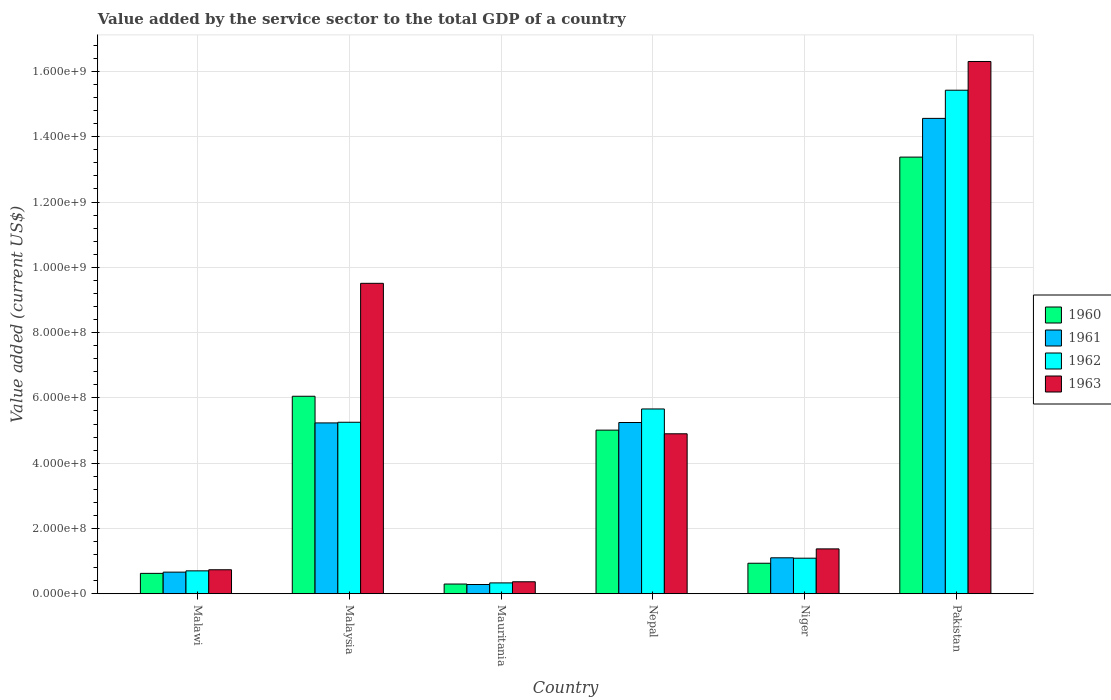How many different coloured bars are there?
Ensure brevity in your answer.  4. How many groups of bars are there?
Provide a succinct answer. 6. Are the number of bars per tick equal to the number of legend labels?
Provide a succinct answer. Yes. Are the number of bars on each tick of the X-axis equal?
Provide a short and direct response. Yes. How many bars are there on the 1st tick from the left?
Offer a very short reply. 4. How many bars are there on the 3rd tick from the right?
Provide a short and direct response. 4. What is the label of the 2nd group of bars from the left?
Provide a short and direct response. Malaysia. What is the value added by the service sector to the total GDP in 1960 in Malaysia?
Offer a terse response. 6.05e+08. Across all countries, what is the maximum value added by the service sector to the total GDP in 1962?
Give a very brief answer. 1.54e+09. Across all countries, what is the minimum value added by the service sector to the total GDP in 1960?
Provide a succinct answer. 2.97e+07. In which country was the value added by the service sector to the total GDP in 1962 minimum?
Ensure brevity in your answer.  Mauritania. What is the total value added by the service sector to the total GDP in 1962 in the graph?
Your answer should be compact. 2.85e+09. What is the difference between the value added by the service sector to the total GDP in 1961 in Malawi and that in Mauritania?
Your answer should be very brief. 3.79e+07. What is the difference between the value added by the service sector to the total GDP in 1962 in Nepal and the value added by the service sector to the total GDP in 1963 in Niger?
Offer a terse response. 4.29e+08. What is the average value added by the service sector to the total GDP in 1962 per country?
Make the answer very short. 4.74e+08. What is the difference between the value added by the service sector to the total GDP of/in 1961 and value added by the service sector to the total GDP of/in 1963 in Niger?
Keep it short and to the point. -2.73e+07. What is the ratio of the value added by the service sector to the total GDP in 1960 in Niger to that in Pakistan?
Keep it short and to the point. 0.07. Is the value added by the service sector to the total GDP in 1961 in Malaysia less than that in Niger?
Offer a very short reply. No. Is the difference between the value added by the service sector to the total GDP in 1961 in Nepal and Niger greater than the difference between the value added by the service sector to the total GDP in 1963 in Nepal and Niger?
Provide a succinct answer. Yes. What is the difference between the highest and the second highest value added by the service sector to the total GDP in 1961?
Your answer should be compact. 9.33e+08. What is the difference between the highest and the lowest value added by the service sector to the total GDP in 1960?
Your answer should be compact. 1.31e+09. Is it the case that in every country, the sum of the value added by the service sector to the total GDP in 1961 and value added by the service sector to the total GDP in 1962 is greater than the sum of value added by the service sector to the total GDP in 1963 and value added by the service sector to the total GDP in 1960?
Keep it short and to the point. No. Is it the case that in every country, the sum of the value added by the service sector to the total GDP in 1962 and value added by the service sector to the total GDP in 1960 is greater than the value added by the service sector to the total GDP in 1963?
Make the answer very short. Yes. How many bars are there?
Give a very brief answer. 24. Are all the bars in the graph horizontal?
Offer a terse response. No. Are the values on the major ticks of Y-axis written in scientific E-notation?
Give a very brief answer. Yes. What is the title of the graph?
Your response must be concise. Value added by the service sector to the total GDP of a country. What is the label or title of the Y-axis?
Give a very brief answer. Value added (current US$). What is the Value added (current US$) of 1960 in Malawi?
Offer a very short reply. 6.24e+07. What is the Value added (current US$) in 1961 in Malawi?
Offer a very short reply. 6.62e+07. What is the Value added (current US$) in 1962 in Malawi?
Provide a succinct answer. 7.01e+07. What is the Value added (current US$) of 1963 in Malawi?
Give a very brief answer. 7.35e+07. What is the Value added (current US$) of 1960 in Malaysia?
Offer a terse response. 6.05e+08. What is the Value added (current US$) in 1961 in Malaysia?
Your answer should be very brief. 5.23e+08. What is the Value added (current US$) in 1962 in Malaysia?
Your answer should be compact. 5.25e+08. What is the Value added (current US$) in 1963 in Malaysia?
Ensure brevity in your answer.  9.51e+08. What is the Value added (current US$) in 1960 in Mauritania?
Give a very brief answer. 2.97e+07. What is the Value added (current US$) of 1961 in Mauritania?
Provide a succinct answer. 2.83e+07. What is the Value added (current US$) in 1962 in Mauritania?
Give a very brief answer. 3.32e+07. What is the Value added (current US$) in 1963 in Mauritania?
Offer a very short reply. 3.67e+07. What is the Value added (current US$) in 1960 in Nepal?
Make the answer very short. 5.01e+08. What is the Value added (current US$) of 1961 in Nepal?
Your answer should be compact. 5.25e+08. What is the Value added (current US$) in 1962 in Nepal?
Offer a very short reply. 5.66e+08. What is the Value added (current US$) in 1963 in Nepal?
Keep it short and to the point. 4.90e+08. What is the Value added (current US$) of 1960 in Niger?
Offer a very short reply. 9.35e+07. What is the Value added (current US$) of 1961 in Niger?
Your answer should be compact. 1.10e+08. What is the Value added (current US$) in 1962 in Niger?
Give a very brief answer. 1.09e+08. What is the Value added (current US$) in 1963 in Niger?
Keep it short and to the point. 1.37e+08. What is the Value added (current US$) in 1960 in Pakistan?
Provide a succinct answer. 1.34e+09. What is the Value added (current US$) of 1961 in Pakistan?
Ensure brevity in your answer.  1.46e+09. What is the Value added (current US$) of 1962 in Pakistan?
Provide a short and direct response. 1.54e+09. What is the Value added (current US$) in 1963 in Pakistan?
Provide a short and direct response. 1.63e+09. Across all countries, what is the maximum Value added (current US$) in 1960?
Offer a very short reply. 1.34e+09. Across all countries, what is the maximum Value added (current US$) of 1961?
Your answer should be compact. 1.46e+09. Across all countries, what is the maximum Value added (current US$) of 1962?
Your answer should be very brief. 1.54e+09. Across all countries, what is the maximum Value added (current US$) of 1963?
Ensure brevity in your answer.  1.63e+09. Across all countries, what is the minimum Value added (current US$) of 1960?
Provide a short and direct response. 2.97e+07. Across all countries, what is the minimum Value added (current US$) of 1961?
Offer a terse response. 2.83e+07. Across all countries, what is the minimum Value added (current US$) of 1962?
Keep it short and to the point. 3.32e+07. Across all countries, what is the minimum Value added (current US$) in 1963?
Make the answer very short. 3.67e+07. What is the total Value added (current US$) in 1960 in the graph?
Your response must be concise. 2.63e+09. What is the total Value added (current US$) of 1961 in the graph?
Make the answer very short. 2.71e+09. What is the total Value added (current US$) of 1962 in the graph?
Offer a very short reply. 2.85e+09. What is the total Value added (current US$) of 1963 in the graph?
Offer a very short reply. 3.32e+09. What is the difference between the Value added (current US$) of 1960 in Malawi and that in Malaysia?
Keep it short and to the point. -5.43e+08. What is the difference between the Value added (current US$) of 1961 in Malawi and that in Malaysia?
Make the answer very short. -4.57e+08. What is the difference between the Value added (current US$) of 1962 in Malawi and that in Malaysia?
Offer a very short reply. -4.55e+08. What is the difference between the Value added (current US$) of 1963 in Malawi and that in Malaysia?
Make the answer very short. -8.78e+08. What is the difference between the Value added (current US$) of 1960 in Malawi and that in Mauritania?
Provide a short and direct response. 3.27e+07. What is the difference between the Value added (current US$) in 1961 in Malawi and that in Mauritania?
Offer a terse response. 3.79e+07. What is the difference between the Value added (current US$) in 1962 in Malawi and that in Mauritania?
Your answer should be compact. 3.69e+07. What is the difference between the Value added (current US$) in 1963 in Malawi and that in Mauritania?
Provide a short and direct response. 3.68e+07. What is the difference between the Value added (current US$) in 1960 in Malawi and that in Nepal?
Ensure brevity in your answer.  -4.39e+08. What is the difference between the Value added (current US$) in 1961 in Malawi and that in Nepal?
Your answer should be compact. -4.58e+08. What is the difference between the Value added (current US$) in 1962 in Malawi and that in Nepal?
Ensure brevity in your answer.  -4.96e+08. What is the difference between the Value added (current US$) of 1963 in Malawi and that in Nepal?
Offer a terse response. -4.17e+08. What is the difference between the Value added (current US$) in 1960 in Malawi and that in Niger?
Your response must be concise. -3.10e+07. What is the difference between the Value added (current US$) of 1961 in Malawi and that in Niger?
Make the answer very short. -4.39e+07. What is the difference between the Value added (current US$) of 1962 in Malawi and that in Niger?
Your answer should be very brief. -3.88e+07. What is the difference between the Value added (current US$) of 1963 in Malawi and that in Niger?
Your answer should be compact. -6.39e+07. What is the difference between the Value added (current US$) in 1960 in Malawi and that in Pakistan?
Provide a short and direct response. -1.28e+09. What is the difference between the Value added (current US$) in 1961 in Malawi and that in Pakistan?
Give a very brief answer. -1.39e+09. What is the difference between the Value added (current US$) in 1962 in Malawi and that in Pakistan?
Your response must be concise. -1.47e+09. What is the difference between the Value added (current US$) of 1963 in Malawi and that in Pakistan?
Your answer should be compact. -1.56e+09. What is the difference between the Value added (current US$) in 1960 in Malaysia and that in Mauritania?
Your answer should be very brief. 5.75e+08. What is the difference between the Value added (current US$) in 1961 in Malaysia and that in Mauritania?
Offer a very short reply. 4.95e+08. What is the difference between the Value added (current US$) in 1962 in Malaysia and that in Mauritania?
Your response must be concise. 4.92e+08. What is the difference between the Value added (current US$) in 1963 in Malaysia and that in Mauritania?
Make the answer very short. 9.14e+08. What is the difference between the Value added (current US$) of 1960 in Malaysia and that in Nepal?
Give a very brief answer. 1.04e+08. What is the difference between the Value added (current US$) of 1961 in Malaysia and that in Nepal?
Give a very brief answer. -1.26e+06. What is the difference between the Value added (current US$) of 1962 in Malaysia and that in Nepal?
Your answer should be compact. -4.07e+07. What is the difference between the Value added (current US$) of 1963 in Malaysia and that in Nepal?
Make the answer very short. 4.61e+08. What is the difference between the Value added (current US$) in 1960 in Malaysia and that in Niger?
Offer a terse response. 5.12e+08. What is the difference between the Value added (current US$) in 1961 in Malaysia and that in Niger?
Offer a very short reply. 4.13e+08. What is the difference between the Value added (current US$) in 1962 in Malaysia and that in Niger?
Your answer should be compact. 4.16e+08. What is the difference between the Value added (current US$) of 1963 in Malaysia and that in Niger?
Ensure brevity in your answer.  8.14e+08. What is the difference between the Value added (current US$) of 1960 in Malaysia and that in Pakistan?
Provide a short and direct response. -7.33e+08. What is the difference between the Value added (current US$) in 1961 in Malaysia and that in Pakistan?
Your answer should be compact. -9.33e+08. What is the difference between the Value added (current US$) in 1962 in Malaysia and that in Pakistan?
Your answer should be compact. -1.02e+09. What is the difference between the Value added (current US$) of 1963 in Malaysia and that in Pakistan?
Offer a very short reply. -6.80e+08. What is the difference between the Value added (current US$) of 1960 in Mauritania and that in Nepal?
Your response must be concise. -4.72e+08. What is the difference between the Value added (current US$) in 1961 in Mauritania and that in Nepal?
Your response must be concise. -4.96e+08. What is the difference between the Value added (current US$) in 1962 in Mauritania and that in Nepal?
Provide a short and direct response. -5.33e+08. What is the difference between the Value added (current US$) of 1963 in Mauritania and that in Nepal?
Your answer should be very brief. -4.53e+08. What is the difference between the Value added (current US$) in 1960 in Mauritania and that in Niger?
Offer a terse response. -6.37e+07. What is the difference between the Value added (current US$) of 1961 in Mauritania and that in Niger?
Make the answer very short. -8.18e+07. What is the difference between the Value added (current US$) of 1962 in Mauritania and that in Niger?
Give a very brief answer. -7.57e+07. What is the difference between the Value added (current US$) of 1963 in Mauritania and that in Niger?
Ensure brevity in your answer.  -1.01e+08. What is the difference between the Value added (current US$) of 1960 in Mauritania and that in Pakistan?
Provide a short and direct response. -1.31e+09. What is the difference between the Value added (current US$) in 1961 in Mauritania and that in Pakistan?
Keep it short and to the point. -1.43e+09. What is the difference between the Value added (current US$) in 1962 in Mauritania and that in Pakistan?
Give a very brief answer. -1.51e+09. What is the difference between the Value added (current US$) in 1963 in Mauritania and that in Pakistan?
Your answer should be very brief. -1.59e+09. What is the difference between the Value added (current US$) of 1960 in Nepal and that in Niger?
Provide a short and direct response. 4.08e+08. What is the difference between the Value added (current US$) of 1961 in Nepal and that in Niger?
Provide a succinct answer. 4.14e+08. What is the difference between the Value added (current US$) in 1962 in Nepal and that in Niger?
Make the answer very short. 4.57e+08. What is the difference between the Value added (current US$) in 1963 in Nepal and that in Niger?
Offer a very short reply. 3.53e+08. What is the difference between the Value added (current US$) of 1960 in Nepal and that in Pakistan?
Provide a short and direct response. -8.36e+08. What is the difference between the Value added (current US$) in 1961 in Nepal and that in Pakistan?
Give a very brief answer. -9.32e+08. What is the difference between the Value added (current US$) in 1962 in Nepal and that in Pakistan?
Give a very brief answer. -9.77e+08. What is the difference between the Value added (current US$) in 1963 in Nepal and that in Pakistan?
Keep it short and to the point. -1.14e+09. What is the difference between the Value added (current US$) in 1960 in Niger and that in Pakistan?
Your answer should be compact. -1.24e+09. What is the difference between the Value added (current US$) of 1961 in Niger and that in Pakistan?
Ensure brevity in your answer.  -1.35e+09. What is the difference between the Value added (current US$) in 1962 in Niger and that in Pakistan?
Your answer should be compact. -1.43e+09. What is the difference between the Value added (current US$) in 1963 in Niger and that in Pakistan?
Ensure brevity in your answer.  -1.49e+09. What is the difference between the Value added (current US$) of 1960 in Malawi and the Value added (current US$) of 1961 in Malaysia?
Provide a succinct answer. -4.61e+08. What is the difference between the Value added (current US$) of 1960 in Malawi and the Value added (current US$) of 1962 in Malaysia?
Ensure brevity in your answer.  -4.63e+08. What is the difference between the Value added (current US$) in 1960 in Malawi and the Value added (current US$) in 1963 in Malaysia?
Make the answer very short. -8.89e+08. What is the difference between the Value added (current US$) of 1961 in Malawi and the Value added (current US$) of 1962 in Malaysia?
Keep it short and to the point. -4.59e+08. What is the difference between the Value added (current US$) of 1961 in Malawi and the Value added (current US$) of 1963 in Malaysia?
Provide a succinct answer. -8.85e+08. What is the difference between the Value added (current US$) in 1962 in Malawi and the Value added (current US$) in 1963 in Malaysia?
Your response must be concise. -8.81e+08. What is the difference between the Value added (current US$) of 1960 in Malawi and the Value added (current US$) of 1961 in Mauritania?
Your response must be concise. 3.41e+07. What is the difference between the Value added (current US$) in 1960 in Malawi and the Value added (current US$) in 1962 in Mauritania?
Give a very brief answer. 2.92e+07. What is the difference between the Value added (current US$) of 1960 in Malawi and the Value added (current US$) of 1963 in Mauritania?
Offer a terse response. 2.58e+07. What is the difference between the Value added (current US$) of 1961 in Malawi and the Value added (current US$) of 1962 in Mauritania?
Your response must be concise. 3.30e+07. What is the difference between the Value added (current US$) of 1961 in Malawi and the Value added (current US$) of 1963 in Mauritania?
Your answer should be very brief. 2.96e+07. What is the difference between the Value added (current US$) in 1962 in Malawi and the Value added (current US$) in 1963 in Mauritania?
Your response must be concise. 3.35e+07. What is the difference between the Value added (current US$) of 1960 in Malawi and the Value added (current US$) of 1961 in Nepal?
Your answer should be compact. -4.62e+08. What is the difference between the Value added (current US$) in 1960 in Malawi and the Value added (current US$) in 1962 in Nepal?
Provide a succinct answer. -5.04e+08. What is the difference between the Value added (current US$) of 1960 in Malawi and the Value added (current US$) of 1963 in Nepal?
Keep it short and to the point. -4.28e+08. What is the difference between the Value added (current US$) of 1961 in Malawi and the Value added (current US$) of 1962 in Nepal?
Ensure brevity in your answer.  -5.00e+08. What is the difference between the Value added (current US$) in 1961 in Malawi and the Value added (current US$) in 1963 in Nepal?
Provide a succinct answer. -4.24e+08. What is the difference between the Value added (current US$) in 1962 in Malawi and the Value added (current US$) in 1963 in Nepal?
Make the answer very short. -4.20e+08. What is the difference between the Value added (current US$) of 1960 in Malawi and the Value added (current US$) of 1961 in Niger?
Your answer should be very brief. -4.77e+07. What is the difference between the Value added (current US$) of 1960 in Malawi and the Value added (current US$) of 1962 in Niger?
Offer a very short reply. -4.65e+07. What is the difference between the Value added (current US$) of 1960 in Malawi and the Value added (current US$) of 1963 in Niger?
Give a very brief answer. -7.50e+07. What is the difference between the Value added (current US$) of 1961 in Malawi and the Value added (current US$) of 1962 in Niger?
Your answer should be very brief. -4.27e+07. What is the difference between the Value added (current US$) in 1961 in Malawi and the Value added (current US$) in 1963 in Niger?
Your response must be concise. -7.12e+07. What is the difference between the Value added (current US$) of 1962 in Malawi and the Value added (current US$) of 1963 in Niger?
Keep it short and to the point. -6.73e+07. What is the difference between the Value added (current US$) of 1960 in Malawi and the Value added (current US$) of 1961 in Pakistan?
Your answer should be very brief. -1.39e+09. What is the difference between the Value added (current US$) in 1960 in Malawi and the Value added (current US$) in 1962 in Pakistan?
Your response must be concise. -1.48e+09. What is the difference between the Value added (current US$) of 1960 in Malawi and the Value added (current US$) of 1963 in Pakistan?
Keep it short and to the point. -1.57e+09. What is the difference between the Value added (current US$) of 1961 in Malawi and the Value added (current US$) of 1962 in Pakistan?
Ensure brevity in your answer.  -1.48e+09. What is the difference between the Value added (current US$) in 1961 in Malawi and the Value added (current US$) in 1963 in Pakistan?
Keep it short and to the point. -1.56e+09. What is the difference between the Value added (current US$) of 1962 in Malawi and the Value added (current US$) of 1963 in Pakistan?
Your answer should be compact. -1.56e+09. What is the difference between the Value added (current US$) of 1960 in Malaysia and the Value added (current US$) of 1961 in Mauritania?
Keep it short and to the point. 5.77e+08. What is the difference between the Value added (current US$) in 1960 in Malaysia and the Value added (current US$) in 1962 in Mauritania?
Your answer should be compact. 5.72e+08. What is the difference between the Value added (current US$) in 1960 in Malaysia and the Value added (current US$) in 1963 in Mauritania?
Provide a succinct answer. 5.68e+08. What is the difference between the Value added (current US$) of 1961 in Malaysia and the Value added (current US$) of 1962 in Mauritania?
Make the answer very short. 4.90e+08. What is the difference between the Value added (current US$) of 1961 in Malaysia and the Value added (current US$) of 1963 in Mauritania?
Your response must be concise. 4.87e+08. What is the difference between the Value added (current US$) in 1962 in Malaysia and the Value added (current US$) in 1963 in Mauritania?
Your response must be concise. 4.89e+08. What is the difference between the Value added (current US$) in 1960 in Malaysia and the Value added (current US$) in 1961 in Nepal?
Provide a short and direct response. 8.04e+07. What is the difference between the Value added (current US$) of 1960 in Malaysia and the Value added (current US$) of 1962 in Nepal?
Provide a short and direct response. 3.89e+07. What is the difference between the Value added (current US$) of 1960 in Malaysia and the Value added (current US$) of 1963 in Nepal?
Keep it short and to the point. 1.15e+08. What is the difference between the Value added (current US$) of 1961 in Malaysia and the Value added (current US$) of 1962 in Nepal?
Offer a very short reply. -4.27e+07. What is the difference between the Value added (current US$) in 1961 in Malaysia and the Value added (current US$) in 1963 in Nepal?
Offer a very short reply. 3.33e+07. What is the difference between the Value added (current US$) in 1962 in Malaysia and the Value added (current US$) in 1963 in Nepal?
Offer a very short reply. 3.53e+07. What is the difference between the Value added (current US$) in 1960 in Malaysia and the Value added (current US$) in 1961 in Niger?
Provide a succinct answer. 4.95e+08. What is the difference between the Value added (current US$) in 1960 in Malaysia and the Value added (current US$) in 1962 in Niger?
Provide a short and direct response. 4.96e+08. What is the difference between the Value added (current US$) of 1960 in Malaysia and the Value added (current US$) of 1963 in Niger?
Provide a succinct answer. 4.68e+08. What is the difference between the Value added (current US$) in 1961 in Malaysia and the Value added (current US$) in 1962 in Niger?
Provide a succinct answer. 4.14e+08. What is the difference between the Value added (current US$) in 1961 in Malaysia and the Value added (current US$) in 1963 in Niger?
Offer a terse response. 3.86e+08. What is the difference between the Value added (current US$) in 1962 in Malaysia and the Value added (current US$) in 1963 in Niger?
Your answer should be compact. 3.88e+08. What is the difference between the Value added (current US$) in 1960 in Malaysia and the Value added (current US$) in 1961 in Pakistan?
Your response must be concise. -8.51e+08. What is the difference between the Value added (current US$) in 1960 in Malaysia and the Value added (current US$) in 1962 in Pakistan?
Make the answer very short. -9.38e+08. What is the difference between the Value added (current US$) in 1960 in Malaysia and the Value added (current US$) in 1963 in Pakistan?
Offer a terse response. -1.03e+09. What is the difference between the Value added (current US$) of 1961 in Malaysia and the Value added (current US$) of 1962 in Pakistan?
Make the answer very short. -1.02e+09. What is the difference between the Value added (current US$) in 1961 in Malaysia and the Value added (current US$) in 1963 in Pakistan?
Ensure brevity in your answer.  -1.11e+09. What is the difference between the Value added (current US$) of 1962 in Malaysia and the Value added (current US$) of 1963 in Pakistan?
Offer a very short reply. -1.11e+09. What is the difference between the Value added (current US$) of 1960 in Mauritania and the Value added (current US$) of 1961 in Nepal?
Your answer should be compact. -4.95e+08. What is the difference between the Value added (current US$) of 1960 in Mauritania and the Value added (current US$) of 1962 in Nepal?
Offer a terse response. -5.36e+08. What is the difference between the Value added (current US$) in 1960 in Mauritania and the Value added (current US$) in 1963 in Nepal?
Provide a succinct answer. -4.60e+08. What is the difference between the Value added (current US$) in 1961 in Mauritania and the Value added (current US$) in 1962 in Nepal?
Your response must be concise. -5.38e+08. What is the difference between the Value added (current US$) in 1961 in Mauritania and the Value added (current US$) in 1963 in Nepal?
Your response must be concise. -4.62e+08. What is the difference between the Value added (current US$) in 1962 in Mauritania and the Value added (current US$) in 1963 in Nepal?
Your response must be concise. -4.57e+08. What is the difference between the Value added (current US$) in 1960 in Mauritania and the Value added (current US$) in 1961 in Niger?
Offer a terse response. -8.04e+07. What is the difference between the Value added (current US$) in 1960 in Mauritania and the Value added (current US$) in 1962 in Niger?
Your answer should be very brief. -7.92e+07. What is the difference between the Value added (current US$) in 1960 in Mauritania and the Value added (current US$) in 1963 in Niger?
Your answer should be compact. -1.08e+08. What is the difference between the Value added (current US$) of 1961 in Mauritania and the Value added (current US$) of 1962 in Niger?
Offer a very short reply. -8.06e+07. What is the difference between the Value added (current US$) in 1961 in Mauritania and the Value added (current US$) in 1963 in Niger?
Offer a very short reply. -1.09e+08. What is the difference between the Value added (current US$) in 1962 in Mauritania and the Value added (current US$) in 1963 in Niger?
Your answer should be very brief. -1.04e+08. What is the difference between the Value added (current US$) in 1960 in Mauritania and the Value added (current US$) in 1961 in Pakistan?
Your response must be concise. -1.43e+09. What is the difference between the Value added (current US$) of 1960 in Mauritania and the Value added (current US$) of 1962 in Pakistan?
Provide a short and direct response. -1.51e+09. What is the difference between the Value added (current US$) in 1960 in Mauritania and the Value added (current US$) in 1963 in Pakistan?
Ensure brevity in your answer.  -1.60e+09. What is the difference between the Value added (current US$) in 1961 in Mauritania and the Value added (current US$) in 1962 in Pakistan?
Your answer should be very brief. -1.51e+09. What is the difference between the Value added (current US$) in 1961 in Mauritania and the Value added (current US$) in 1963 in Pakistan?
Your answer should be compact. -1.60e+09. What is the difference between the Value added (current US$) in 1962 in Mauritania and the Value added (current US$) in 1963 in Pakistan?
Offer a very short reply. -1.60e+09. What is the difference between the Value added (current US$) in 1960 in Nepal and the Value added (current US$) in 1961 in Niger?
Ensure brevity in your answer.  3.91e+08. What is the difference between the Value added (current US$) of 1960 in Nepal and the Value added (current US$) of 1962 in Niger?
Ensure brevity in your answer.  3.92e+08. What is the difference between the Value added (current US$) in 1960 in Nepal and the Value added (current US$) in 1963 in Niger?
Provide a succinct answer. 3.64e+08. What is the difference between the Value added (current US$) of 1961 in Nepal and the Value added (current US$) of 1962 in Niger?
Give a very brief answer. 4.16e+08. What is the difference between the Value added (current US$) in 1961 in Nepal and the Value added (current US$) in 1963 in Niger?
Your answer should be compact. 3.87e+08. What is the difference between the Value added (current US$) in 1962 in Nepal and the Value added (current US$) in 1963 in Niger?
Give a very brief answer. 4.29e+08. What is the difference between the Value added (current US$) of 1960 in Nepal and the Value added (current US$) of 1961 in Pakistan?
Keep it short and to the point. -9.55e+08. What is the difference between the Value added (current US$) of 1960 in Nepal and the Value added (current US$) of 1962 in Pakistan?
Keep it short and to the point. -1.04e+09. What is the difference between the Value added (current US$) of 1960 in Nepal and the Value added (current US$) of 1963 in Pakistan?
Provide a succinct answer. -1.13e+09. What is the difference between the Value added (current US$) of 1961 in Nepal and the Value added (current US$) of 1962 in Pakistan?
Make the answer very short. -1.02e+09. What is the difference between the Value added (current US$) of 1961 in Nepal and the Value added (current US$) of 1963 in Pakistan?
Make the answer very short. -1.11e+09. What is the difference between the Value added (current US$) in 1962 in Nepal and the Value added (current US$) in 1963 in Pakistan?
Offer a terse response. -1.06e+09. What is the difference between the Value added (current US$) in 1960 in Niger and the Value added (current US$) in 1961 in Pakistan?
Your answer should be very brief. -1.36e+09. What is the difference between the Value added (current US$) in 1960 in Niger and the Value added (current US$) in 1962 in Pakistan?
Ensure brevity in your answer.  -1.45e+09. What is the difference between the Value added (current US$) of 1960 in Niger and the Value added (current US$) of 1963 in Pakistan?
Ensure brevity in your answer.  -1.54e+09. What is the difference between the Value added (current US$) of 1961 in Niger and the Value added (current US$) of 1962 in Pakistan?
Offer a terse response. -1.43e+09. What is the difference between the Value added (current US$) in 1961 in Niger and the Value added (current US$) in 1963 in Pakistan?
Offer a very short reply. -1.52e+09. What is the difference between the Value added (current US$) in 1962 in Niger and the Value added (current US$) in 1963 in Pakistan?
Offer a terse response. -1.52e+09. What is the average Value added (current US$) of 1960 per country?
Make the answer very short. 4.38e+08. What is the average Value added (current US$) of 1961 per country?
Make the answer very short. 4.51e+08. What is the average Value added (current US$) of 1962 per country?
Provide a succinct answer. 4.74e+08. What is the average Value added (current US$) in 1963 per country?
Your response must be concise. 5.53e+08. What is the difference between the Value added (current US$) in 1960 and Value added (current US$) in 1961 in Malawi?
Provide a short and direct response. -3.78e+06. What is the difference between the Value added (current US$) of 1960 and Value added (current US$) of 1962 in Malawi?
Your response must be concise. -7.70e+06. What is the difference between the Value added (current US$) of 1960 and Value added (current US$) of 1963 in Malawi?
Your response must be concise. -1.11e+07. What is the difference between the Value added (current US$) of 1961 and Value added (current US$) of 1962 in Malawi?
Provide a succinct answer. -3.92e+06. What is the difference between the Value added (current US$) of 1961 and Value added (current US$) of 1963 in Malawi?
Ensure brevity in your answer.  -7.28e+06. What is the difference between the Value added (current US$) of 1962 and Value added (current US$) of 1963 in Malawi?
Your response must be concise. -3.36e+06. What is the difference between the Value added (current US$) of 1960 and Value added (current US$) of 1961 in Malaysia?
Your answer should be compact. 8.16e+07. What is the difference between the Value added (current US$) in 1960 and Value added (current US$) in 1962 in Malaysia?
Offer a terse response. 7.96e+07. What is the difference between the Value added (current US$) of 1960 and Value added (current US$) of 1963 in Malaysia?
Provide a short and direct response. -3.46e+08. What is the difference between the Value added (current US$) in 1961 and Value added (current US$) in 1962 in Malaysia?
Make the answer very short. -2.03e+06. What is the difference between the Value added (current US$) of 1961 and Value added (current US$) of 1963 in Malaysia?
Provide a short and direct response. -4.28e+08. What is the difference between the Value added (current US$) in 1962 and Value added (current US$) in 1963 in Malaysia?
Offer a terse response. -4.26e+08. What is the difference between the Value added (current US$) of 1960 and Value added (current US$) of 1961 in Mauritania?
Provide a short and direct response. 1.42e+06. What is the difference between the Value added (current US$) of 1960 and Value added (current US$) of 1962 in Mauritania?
Give a very brief answer. -3.51e+06. What is the difference between the Value added (current US$) in 1960 and Value added (current US$) in 1963 in Mauritania?
Keep it short and to the point. -6.94e+06. What is the difference between the Value added (current US$) in 1961 and Value added (current US$) in 1962 in Mauritania?
Provide a succinct answer. -4.93e+06. What is the difference between the Value added (current US$) of 1961 and Value added (current US$) of 1963 in Mauritania?
Keep it short and to the point. -8.35e+06. What is the difference between the Value added (current US$) in 1962 and Value added (current US$) in 1963 in Mauritania?
Provide a short and direct response. -3.42e+06. What is the difference between the Value added (current US$) of 1960 and Value added (current US$) of 1961 in Nepal?
Offer a terse response. -2.34e+07. What is the difference between the Value added (current US$) in 1960 and Value added (current US$) in 1962 in Nepal?
Ensure brevity in your answer.  -6.48e+07. What is the difference between the Value added (current US$) of 1960 and Value added (current US$) of 1963 in Nepal?
Keep it short and to the point. 1.12e+07. What is the difference between the Value added (current US$) of 1961 and Value added (current US$) of 1962 in Nepal?
Your answer should be very brief. -4.15e+07. What is the difference between the Value added (current US$) of 1961 and Value added (current US$) of 1963 in Nepal?
Your response must be concise. 3.46e+07. What is the difference between the Value added (current US$) of 1962 and Value added (current US$) of 1963 in Nepal?
Keep it short and to the point. 7.60e+07. What is the difference between the Value added (current US$) of 1960 and Value added (current US$) of 1961 in Niger?
Offer a very short reply. -1.67e+07. What is the difference between the Value added (current US$) of 1960 and Value added (current US$) of 1962 in Niger?
Your response must be concise. -1.55e+07. What is the difference between the Value added (current US$) of 1960 and Value added (current US$) of 1963 in Niger?
Offer a very short reply. -4.40e+07. What is the difference between the Value added (current US$) in 1961 and Value added (current US$) in 1962 in Niger?
Give a very brief answer. 1.20e+06. What is the difference between the Value added (current US$) in 1961 and Value added (current US$) in 1963 in Niger?
Your response must be concise. -2.73e+07. What is the difference between the Value added (current US$) in 1962 and Value added (current US$) in 1963 in Niger?
Offer a terse response. -2.85e+07. What is the difference between the Value added (current US$) in 1960 and Value added (current US$) in 1961 in Pakistan?
Your answer should be compact. -1.19e+08. What is the difference between the Value added (current US$) of 1960 and Value added (current US$) of 1962 in Pakistan?
Provide a short and direct response. -2.05e+08. What is the difference between the Value added (current US$) in 1960 and Value added (current US$) in 1963 in Pakistan?
Provide a succinct answer. -2.93e+08. What is the difference between the Value added (current US$) of 1961 and Value added (current US$) of 1962 in Pakistan?
Your answer should be compact. -8.63e+07. What is the difference between the Value added (current US$) in 1961 and Value added (current US$) in 1963 in Pakistan?
Your response must be concise. -1.74e+08. What is the difference between the Value added (current US$) in 1962 and Value added (current US$) in 1963 in Pakistan?
Provide a short and direct response. -8.80e+07. What is the ratio of the Value added (current US$) of 1960 in Malawi to that in Malaysia?
Ensure brevity in your answer.  0.1. What is the ratio of the Value added (current US$) of 1961 in Malawi to that in Malaysia?
Your answer should be very brief. 0.13. What is the ratio of the Value added (current US$) of 1962 in Malawi to that in Malaysia?
Provide a succinct answer. 0.13. What is the ratio of the Value added (current US$) of 1963 in Malawi to that in Malaysia?
Provide a short and direct response. 0.08. What is the ratio of the Value added (current US$) in 1960 in Malawi to that in Mauritania?
Make the answer very short. 2.1. What is the ratio of the Value added (current US$) of 1961 in Malawi to that in Mauritania?
Keep it short and to the point. 2.34. What is the ratio of the Value added (current US$) in 1962 in Malawi to that in Mauritania?
Offer a terse response. 2.11. What is the ratio of the Value added (current US$) of 1963 in Malawi to that in Mauritania?
Ensure brevity in your answer.  2.01. What is the ratio of the Value added (current US$) of 1960 in Malawi to that in Nepal?
Provide a short and direct response. 0.12. What is the ratio of the Value added (current US$) of 1961 in Malawi to that in Nepal?
Offer a very short reply. 0.13. What is the ratio of the Value added (current US$) of 1962 in Malawi to that in Nepal?
Offer a very short reply. 0.12. What is the ratio of the Value added (current US$) of 1963 in Malawi to that in Nepal?
Ensure brevity in your answer.  0.15. What is the ratio of the Value added (current US$) in 1960 in Malawi to that in Niger?
Your answer should be very brief. 0.67. What is the ratio of the Value added (current US$) of 1961 in Malawi to that in Niger?
Offer a very short reply. 0.6. What is the ratio of the Value added (current US$) in 1962 in Malawi to that in Niger?
Offer a very short reply. 0.64. What is the ratio of the Value added (current US$) of 1963 in Malawi to that in Niger?
Give a very brief answer. 0.53. What is the ratio of the Value added (current US$) in 1960 in Malawi to that in Pakistan?
Provide a succinct answer. 0.05. What is the ratio of the Value added (current US$) of 1961 in Malawi to that in Pakistan?
Your answer should be very brief. 0.05. What is the ratio of the Value added (current US$) in 1962 in Malawi to that in Pakistan?
Provide a short and direct response. 0.05. What is the ratio of the Value added (current US$) of 1963 in Malawi to that in Pakistan?
Your answer should be very brief. 0.05. What is the ratio of the Value added (current US$) of 1960 in Malaysia to that in Mauritania?
Provide a short and direct response. 20.36. What is the ratio of the Value added (current US$) of 1961 in Malaysia to that in Mauritania?
Offer a terse response. 18.49. What is the ratio of the Value added (current US$) of 1962 in Malaysia to that in Mauritania?
Offer a very short reply. 15.81. What is the ratio of the Value added (current US$) of 1963 in Malaysia to that in Mauritania?
Offer a terse response. 25.94. What is the ratio of the Value added (current US$) of 1960 in Malaysia to that in Nepal?
Offer a very short reply. 1.21. What is the ratio of the Value added (current US$) of 1961 in Malaysia to that in Nepal?
Make the answer very short. 1. What is the ratio of the Value added (current US$) of 1962 in Malaysia to that in Nepal?
Ensure brevity in your answer.  0.93. What is the ratio of the Value added (current US$) in 1963 in Malaysia to that in Nepal?
Your answer should be very brief. 1.94. What is the ratio of the Value added (current US$) of 1960 in Malaysia to that in Niger?
Make the answer very short. 6.47. What is the ratio of the Value added (current US$) in 1961 in Malaysia to that in Niger?
Ensure brevity in your answer.  4.75. What is the ratio of the Value added (current US$) of 1962 in Malaysia to that in Niger?
Provide a short and direct response. 4.82. What is the ratio of the Value added (current US$) of 1963 in Malaysia to that in Niger?
Give a very brief answer. 6.92. What is the ratio of the Value added (current US$) in 1960 in Malaysia to that in Pakistan?
Keep it short and to the point. 0.45. What is the ratio of the Value added (current US$) in 1961 in Malaysia to that in Pakistan?
Offer a terse response. 0.36. What is the ratio of the Value added (current US$) of 1962 in Malaysia to that in Pakistan?
Offer a very short reply. 0.34. What is the ratio of the Value added (current US$) of 1963 in Malaysia to that in Pakistan?
Ensure brevity in your answer.  0.58. What is the ratio of the Value added (current US$) of 1960 in Mauritania to that in Nepal?
Offer a very short reply. 0.06. What is the ratio of the Value added (current US$) in 1961 in Mauritania to that in Nepal?
Your response must be concise. 0.05. What is the ratio of the Value added (current US$) in 1962 in Mauritania to that in Nepal?
Offer a very short reply. 0.06. What is the ratio of the Value added (current US$) in 1963 in Mauritania to that in Nepal?
Provide a succinct answer. 0.07. What is the ratio of the Value added (current US$) of 1960 in Mauritania to that in Niger?
Your answer should be very brief. 0.32. What is the ratio of the Value added (current US$) in 1961 in Mauritania to that in Niger?
Make the answer very short. 0.26. What is the ratio of the Value added (current US$) of 1962 in Mauritania to that in Niger?
Your response must be concise. 0.31. What is the ratio of the Value added (current US$) of 1963 in Mauritania to that in Niger?
Your answer should be very brief. 0.27. What is the ratio of the Value added (current US$) in 1960 in Mauritania to that in Pakistan?
Offer a terse response. 0.02. What is the ratio of the Value added (current US$) of 1961 in Mauritania to that in Pakistan?
Give a very brief answer. 0.02. What is the ratio of the Value added (current US$) of 1962 in Mauritania to that in Pakistan?
Provide a short and direct response. 0.02. What is the ratio of the Value added (current US$) of 1963 in Mauritania to that in Pakistan?
Your answer should be compact. 0.02. What is the ratio of the Value added (current US$) of 1960 in Nepal to that in Niger?
Provide a short and direct response. 5.36. What is the ratio of the Value added (current US$) of 1961 in Nepal to that in Niger?
Make the answer very short. 4.76. What is the ratio of the Value added (current US$) in 1962 in Nepal to that in Niger?
Provide a short and direct response. 5.2. What is the ratio of the Value added (current US$) in 1963 in Nepal to that in Niger?
Provide a short and direct response. 3.57. What is the ratio of the Value added (current US$) of 1960 in Nepal to that in Pakistan?
Offer a very short reply. 0.37. What is the ratio of the Value added (current US$) in 1961 in Nepal to that in Pakistan?
Give a very brief answer. 0.36. What is the ratio of the Value added (current US$) in 1962 in Nepal to that in Pakistan?
Ensure brevity in your answer.  0.37. What is the ratio of the Value added (current US$) in 1963 in Nepal to that in Pakistan?
Your response must be concise. 0.3. What is the ratio of the Value added (current US$) in 1960 in Niger to that in Pakistan?
Your answer should be very brief. 0.07. What is the ratio of the Value added (current US$) of 1961 in Niger to that in Pakistan?
Give a very brief answer. 0.08. What is the ratio of the Value added (current US$) in 1962 in Niger to that in Pakistan?
Your answer should be compact. 0.07. What is the ratio of the Value added (current US$) of 1963 in Niger to that in Pakistan?
Offer a very short reply. 0.08. What is the difference between the highest and the second highest Value added (current US$) in 1960?
Your answer should be compact. 7.33e+08. What is the difference between the highest and the second highest Value added (current US$) of 1961?
Your response must be concise. 9.32e+08. What is the difference between the highest and the second highest Value added (current US$) in 1962?
Ensure brevity in your answer.  9.77e+08. What is the difference between the highest and the second highest Value added (current US$) in 1963?
Provide a succinct answer. 6.80e+08. What is the difference between the highest and the lowest Value added (current US$) in 1960?
Offer a terse response. 1.31e+09. What is the difference between the highest and the lowest Value added (current US$) in 1961?
Ensure brevity in your answer.  1.43e+09. What is the difference between the highest and the lowest Value added (current US$) of 1962?
Your response must be concise. 1.51e+09. What is the difference between the highest and the lowest Value added (current US$) in 1963?
Provide a short and direct response. 1.59e+09. 